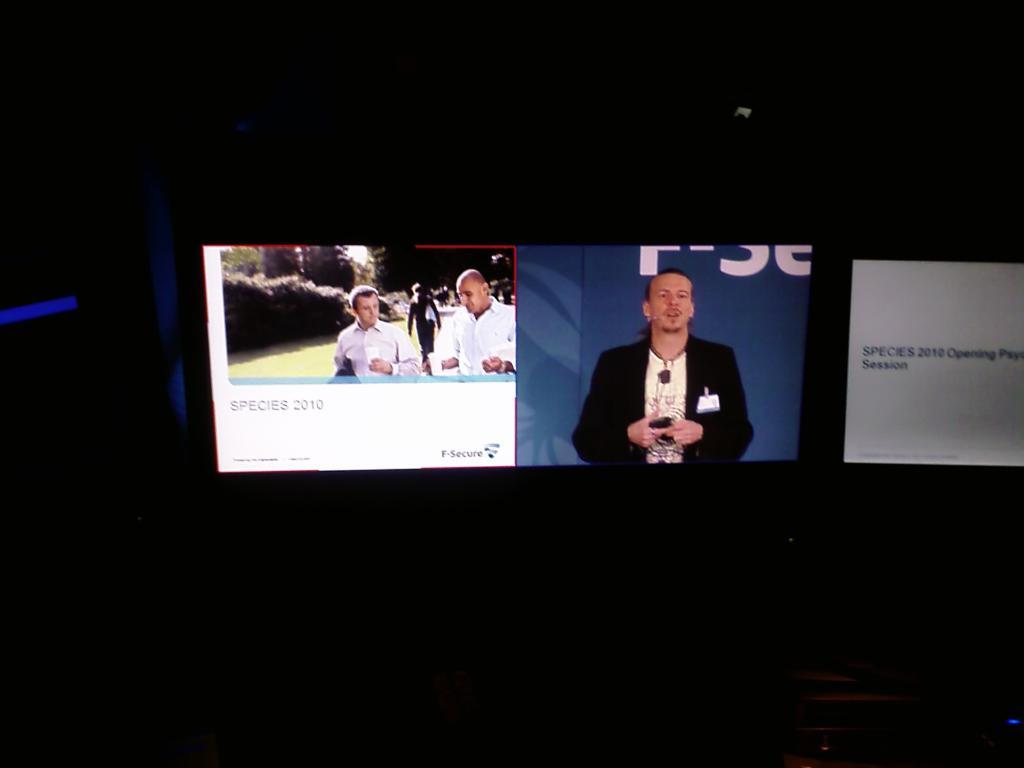Provide a one-sentence caption for the provided image. Three Species 2010 images are on different screens in the dark. 